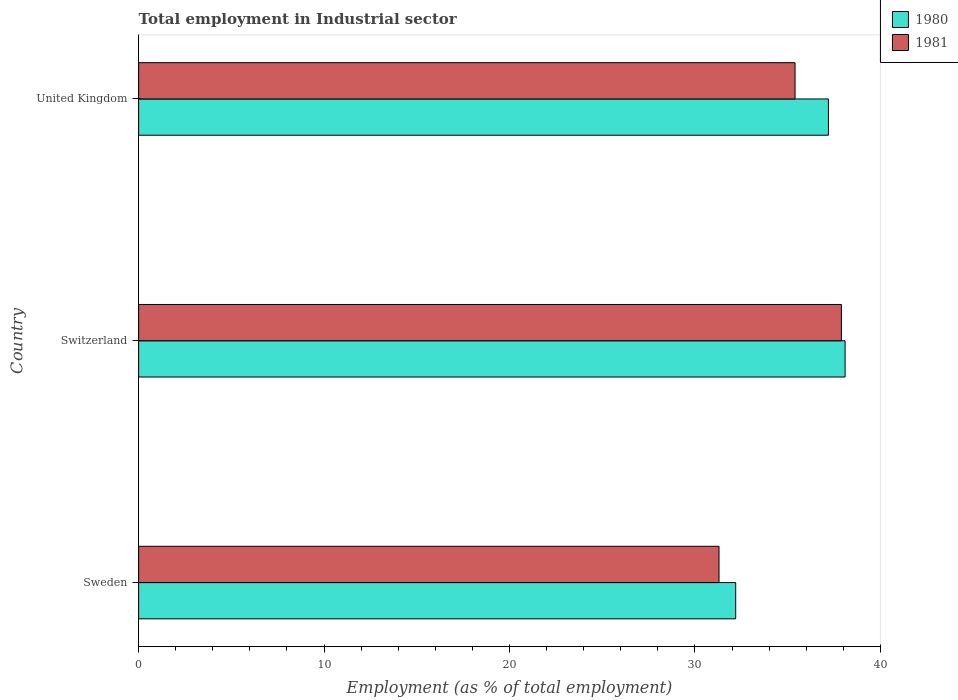How many groups of bars are there?
Give a very brief answer. 3. Are the number of bars on each tick of the Y-axis equal?
Your answer should be very brief. Yes. What is the employment in industrial sector in 1981 in United Kingdom?
Offer a terse response. 35.4. Across all countries, what is the maximum employment in industrial sector in 1980?
Your answer should be very brief. 38.1. Across all countries, what is the minimum employment in industrial sector in 1981?
Keep it short and to the point. 31.3. In which country was the employment in industrial sector in 1981 maximum?
Offer a very short reply. Switzerland. What is the total employment in industrial sector in 1981 in the graph?
Your response must be concise. 104.6. What is the difference between the employment in industrial sector in 1980 in Switzerland and that in United Kingdom?
Provide a succinct answer. 0.9. What is the difference between the employment in industrial sector in 1980 in United Kingdom and the employment in industrial sector in 1981 in Sweden?
Offer a terse response. 5.9. What is the average employment in industrial sector in 1980 per country?
Keep it short and to the point. 35.83. What is the difference between the employment in industrial sector in 1980 and employment in industrial sector in 1981 in United Kingdom?
Keep it short and to the point. 1.8. What is the ratio of the employment in industrial sector in 1981 in Switzerland to that in United Kingdom?
Your response must be concise. 1.07. Is the employment in industrial sector in 1981 in Sweden less than that in United Kingdom?
Give a very brief answer. Yes. Is the difference between the employment in industrial sector in 1980 in Sweden and Switzerland greater than the difference between the employment in industrial sector in 1981 in Sweden and Switzerland?
Keep it short and to the point. Yes. What is the difference between the highest and the second highest employment in industrial sector in 1980?
Your answer should be compact. 0.9. What is the difference between the highest and the lowest employment in industrial sector in 1980?
Your response must be concise. 5.9. Is the sum of the employment in industrial sector in 1980 in Sweden and Switzerland greater than the maximum employment in industrial sector in 1981 across all countries?
Offer a very short reply. Yes. How many bars are there?
Your answer should be compact. 6. Are the values on the major ticks of X-axis written in scientific E-notation?
Offer a terse response. No. Does the graph contain any zero values?
Offer a terse response. No. Does the graph contain grids?
Your response must be concise. No. How are the legend labels stacked?
Your answer should be very brief. Vertical. What is the title of the graph?
Offer a very short reply. Total employment in Industrial sector. Does "1985" appear as one of the legend labels in the graph?
Make the answer very short. No. What is the label or title of the X-axis?
Your answer should be compact. Employment (as % of total employment). What is the label or title of the Y-axis?
Keep it short and to the point. Country. What is the Employment (as % of total employment) in 1980 in Sweden?
Your answer should be very brief. 32.2. What is the Employment (as % of total employment) of 1981 in Sweden?
Offer a terse response. 31.3. What is the Employment (as % of total employment) of 1980 in Switzerland?
Make the answer very short. 38.1. What is the Employment (as % of total employment) of 1981 in Switzerland?
Offer a very short reply. 37.9. What is the Employment (as % of total employment) in 1980 in United Kingdom?
Make the answer very short. 37.2. What is the Employment (as % of total employment) in 1981 in United Kingdom?
Offer a very short reply. 35.4. Across all countries, what is the maximum Employment (as % of total employment) of 1980?
Provide a short and direct response. 38.1. Across all countries, what is the maximum Employment (as % of total employment) in 1981?
Your answer should be very brief. 37.9. Across all countries, what is the minimum Employment (as % of total employment) of 1980?
Provide a succinct answer. 32.2. Across all countries, what is the minimum Employment (as % of total employment) of 1981?
Make the answer very short. 31.3. What is the total Employment (as % of total employment) of 1980 in the graph?
Ensure brevity in your answer.  107.5. What is the total Employment (as % of total employment) of 1981 in the graph?
Provide a succinct answer. 104.6. What is the difference between the Employment (as % of total employment) of 1981 in Sweden and that in Switzerland?
Provide a succinct answer. -6.6. What is the difference between the Employment (as % of total employment) in 1981 in Sweden and that in United Kingdom?
Give a very brief answer. -4.1. What is the difference between the Employment (as % of total employment) of 1980 in Switzerland and that in United Kingdom?
Make the answer very short. 0.9. What is the difference between the Employment (as % of total employment) in 1980 in Sweden and the Employment (as % of total employment) in 1981 in Switzerland?
Your answer should be compact. -5.7. What is the average Employment (as % of total employment) of 1980 per country?
Offer a terse response. 35.83. What is the average Employment (as % of total employment) in 1981 per country?
Your response must be concise. 34.87. What is the difference between the Employment (as % of total employment) in 1980 and Employment (as % of total employment) in 1981 in Sweden?
Make the answer very short. 0.9. What is the difference between the Employment (as % of total employment) of 1980 and Employment (as % of total employment) of 1981 in Switzerland?
Provide a succinct answer. 0.2. What is the difference between the Employment (as % of total employment) of 1980 and Employment (as % of total employment) of 1981 in United Kingdom?
Provide a succinct answer. 1.8. What is the ratio of the Employment (as % of total employment) of 1980 in Sweden to that in Switzerland?
Your response must be concise. 0.85. What is the ratio of the Employment (as % of total employment) of 1981 in Sweden to that in Switzerland?
Provide a short and direct response. 0.83. What is the ratio of the Employment (as % of total employment) of 1980 in Sweden to that in United Kingdom?
Your response must be concise. 0.87. What is the ratio of the Employment (as % of total employment) of 1981 in Sweden to that in United Kingdom?
Ensure brevity in your answer.  0.88. What is the ratio of the Employment (as % of total employment) in 1980 in Switzerland to that in United Kingdom?
Your answer should be very brief. 1.02. What is the ratio of the Employment (as % of total employment) in 1981 in Switzerland to that in United Kingdom?
Your answer should be very brief. 1.07. What is the difference between the highest and the second highest Employment (as % of total employment) in 1981?
Give a very brief answer. 2.5. What is the difference between the highest and the lowest Employment (as % of total employment) of 1980?
Your answer should be compact. 5.9. What is the difference between the highest and the lowest Employment (as % of total employment) of 1981?
Give a very brief answer. 6.6. 